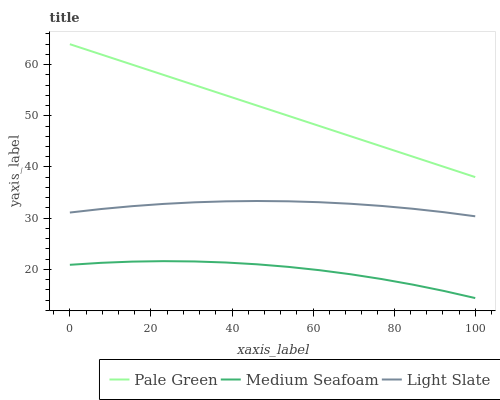Does Pale Green have the minimum area under the curve?
Answer yes or no. No. Does Medium Seafoam have the maximum area under the curve?
Answer yes or no. No. Is Medium Seafoam the smoothest?
Answer yes or no. No. Is Pale Green the roughest?
Answer yes or no. No. Does Pale Green have the lowest value?
Answer yes or no. No. Does Medium Seafoam have the highest value?
Answer yes or no. No. Is Medium Seafoam less than Light Slate?
Answer yes or no. Yes. Is Pale Green greater than Medium Seafoam?
Answer yes or no. Yes. Does Medium Seafoam intersect Light Slate?
Answer yes or no. No. 